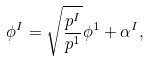<formula> <loc_0><loc_0><loc_500><loc_500>\phi ^ { I } = \sqrt { \frac { p ^ { I } } { p ^ { 1 } } } \phi ^ { 1 } + \alpha ^ { I } ,</formula> 